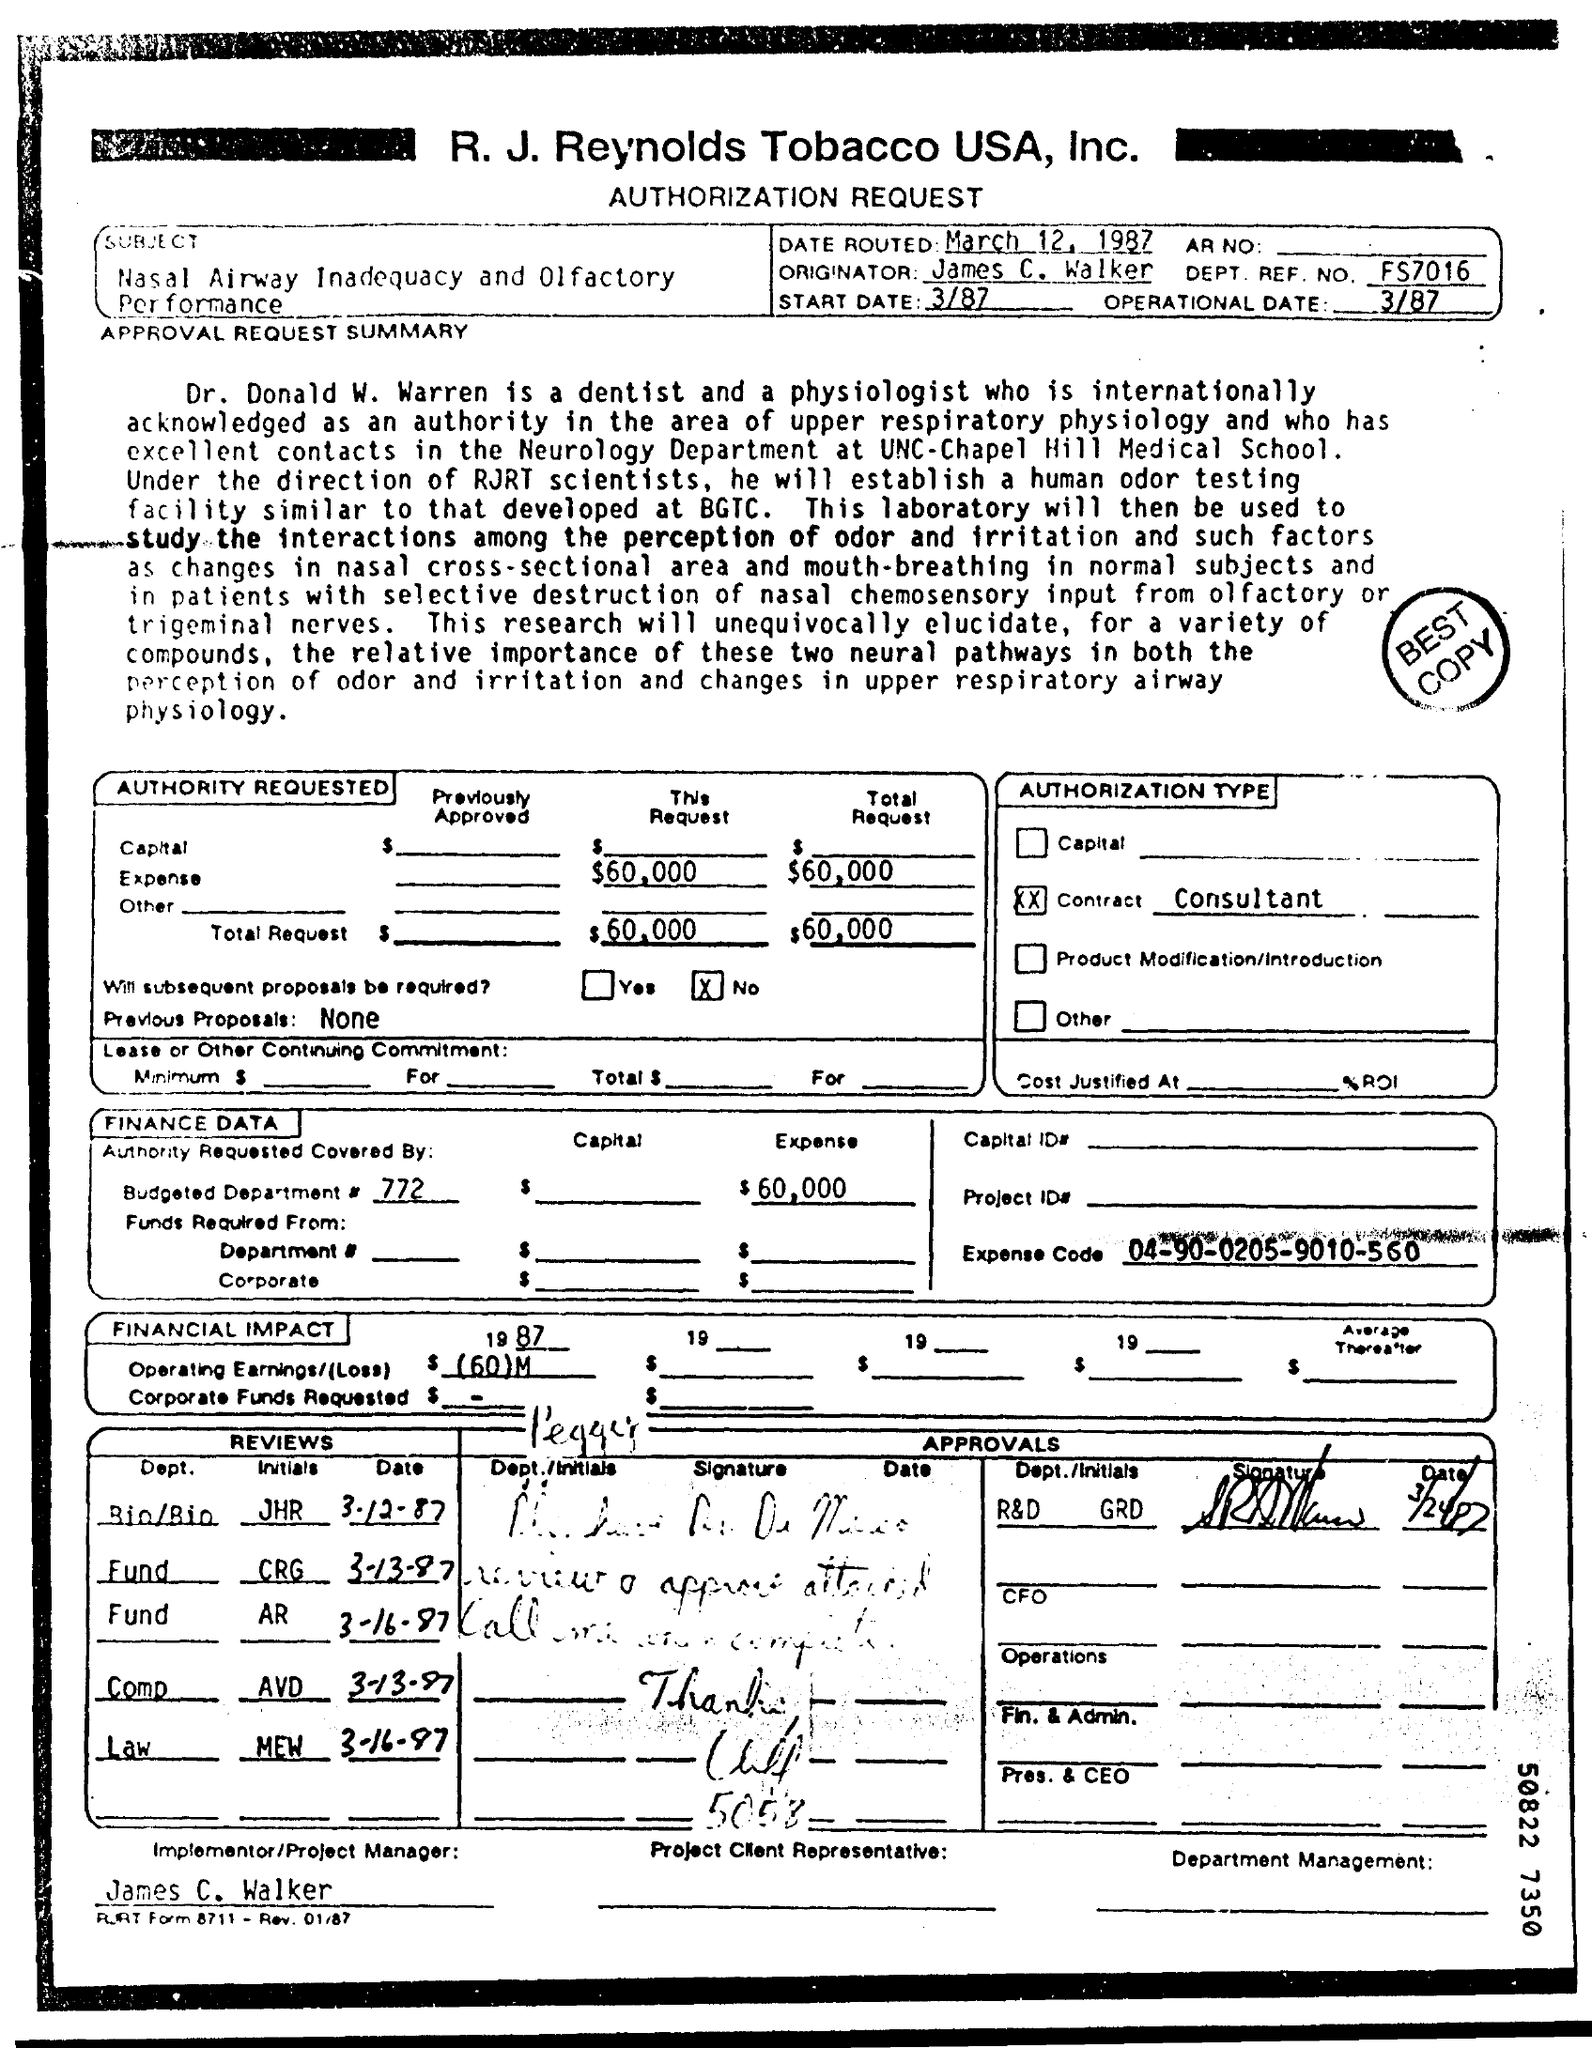What is the subject of the letter?
Give a very brief answer. Nasal Airway Inadequacy and Olfactory Performance. Who is implementer/Project Manager?
Keep it short and to the point. James C. Walker. What is Dr. Donald W Warren by profession?
Your answer should be very brief. Dentist and Physiologist. 